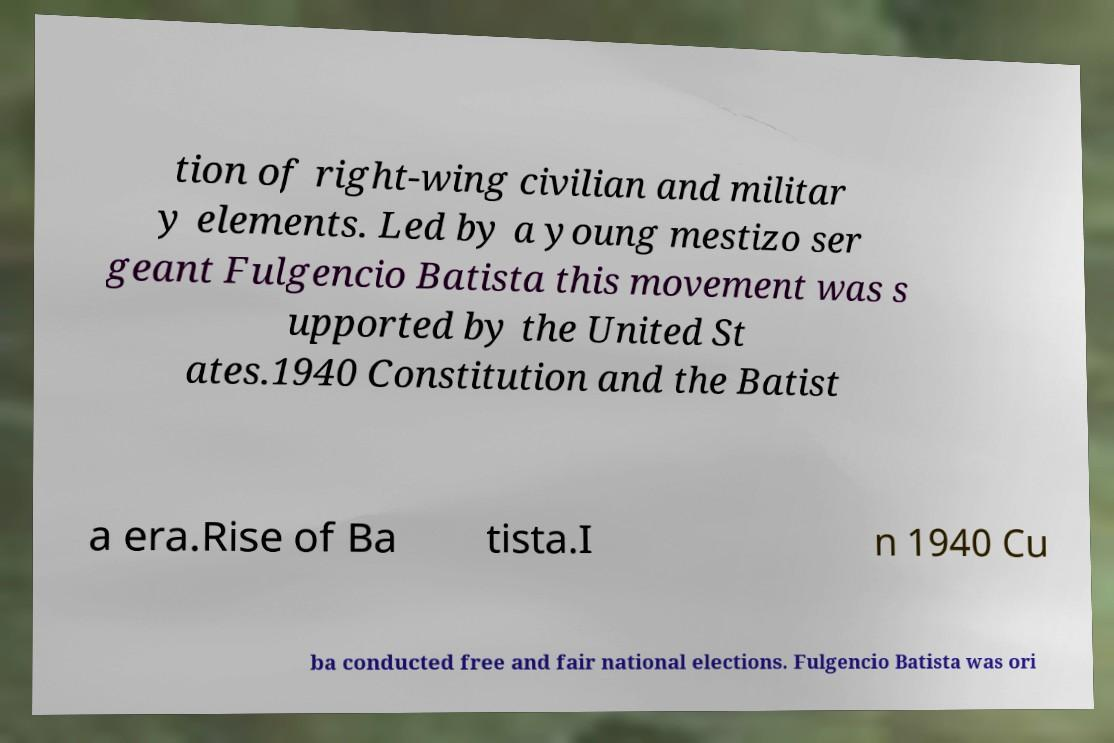Could you extract and type out the text from this image? tion of right-wing civilian and militar y elements. Led by a young mestizo ser geant Fulgencio Batista this movement was s upported by the United St ates.1940 Constitution and the Batist a era.Rise of Ba tista.I n 1940 Cu ba conducted free and fair national elections. Fulgencio Batista was ori 